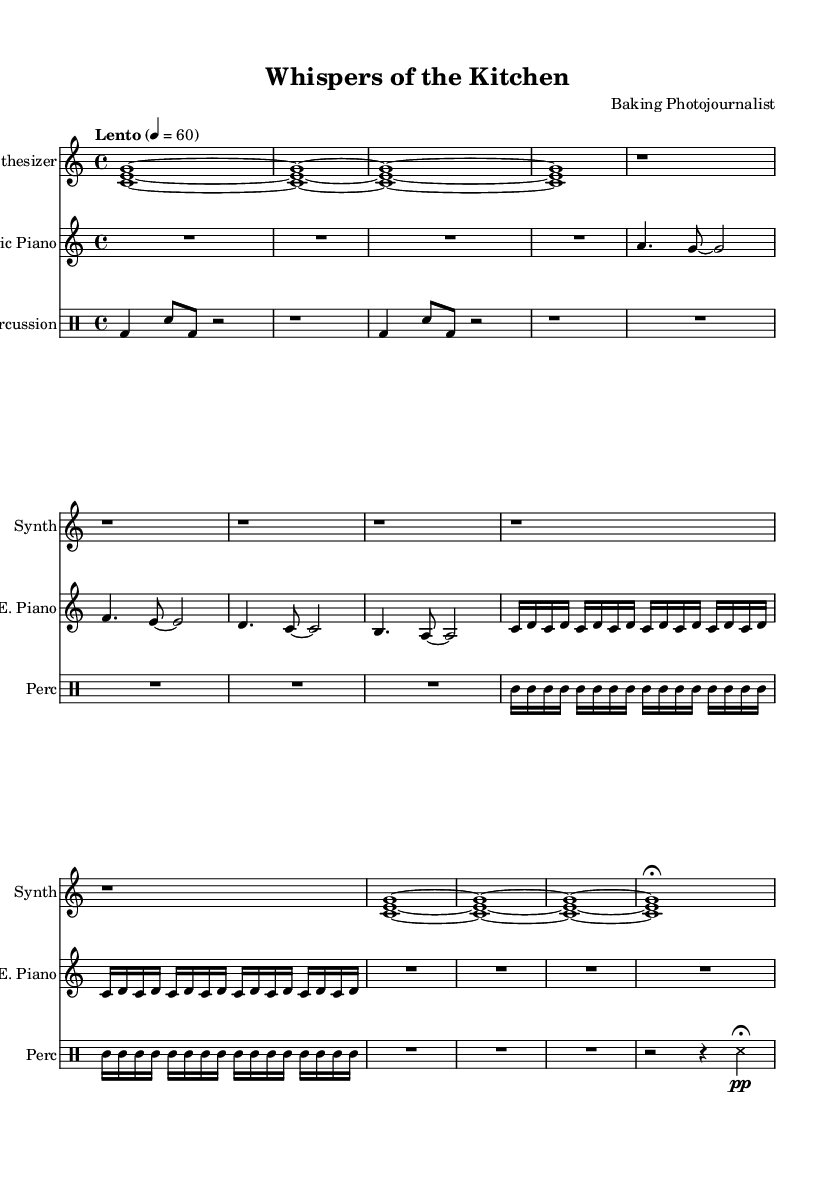What is the time signature of this music? The time signature is indicated as 4/4, which means there are four beats in each measure, and the quarter note gets one beat.
Answer: 4/4 What instruments are used in this sheet music? The sheet music features three instruments: Synthesizer, Electric Piano, and Percussion. Each is specified at the beginning of the respective staff.
Answer: Synthesizer, Electric Piano, Percussion What is the tempo marking in the score? The tempo marking is set to "Lento," which means a slow pace, with a metronome marking of 60 beats per minute.
Answer: Lento 60 How many measures are there in the Introduction section of the Synthesizer? The Introduction consists of four measures, as indicated by the repetition of the same notation across those measures.
Answer: 4 What type of dynamics are indicated in the Percussion section? The score shows a dynamic marking of "pp," which means very quiet, indicating a soft touch for the last part of the Percussion section.
Answer: pp In which section does the Electric Piano have a repeated motif? The Electric Piano features a repeated motif in the Bridge section, where the phrase is repeated multiple times in a rapid succession of notes.
Answer: Bridge How many total notes are in the main theme section of the Electric Piano? The main theme consists of a total of 16 notes, counting the rhythm and the notes in the measures provided for that section.
Answer: 16 